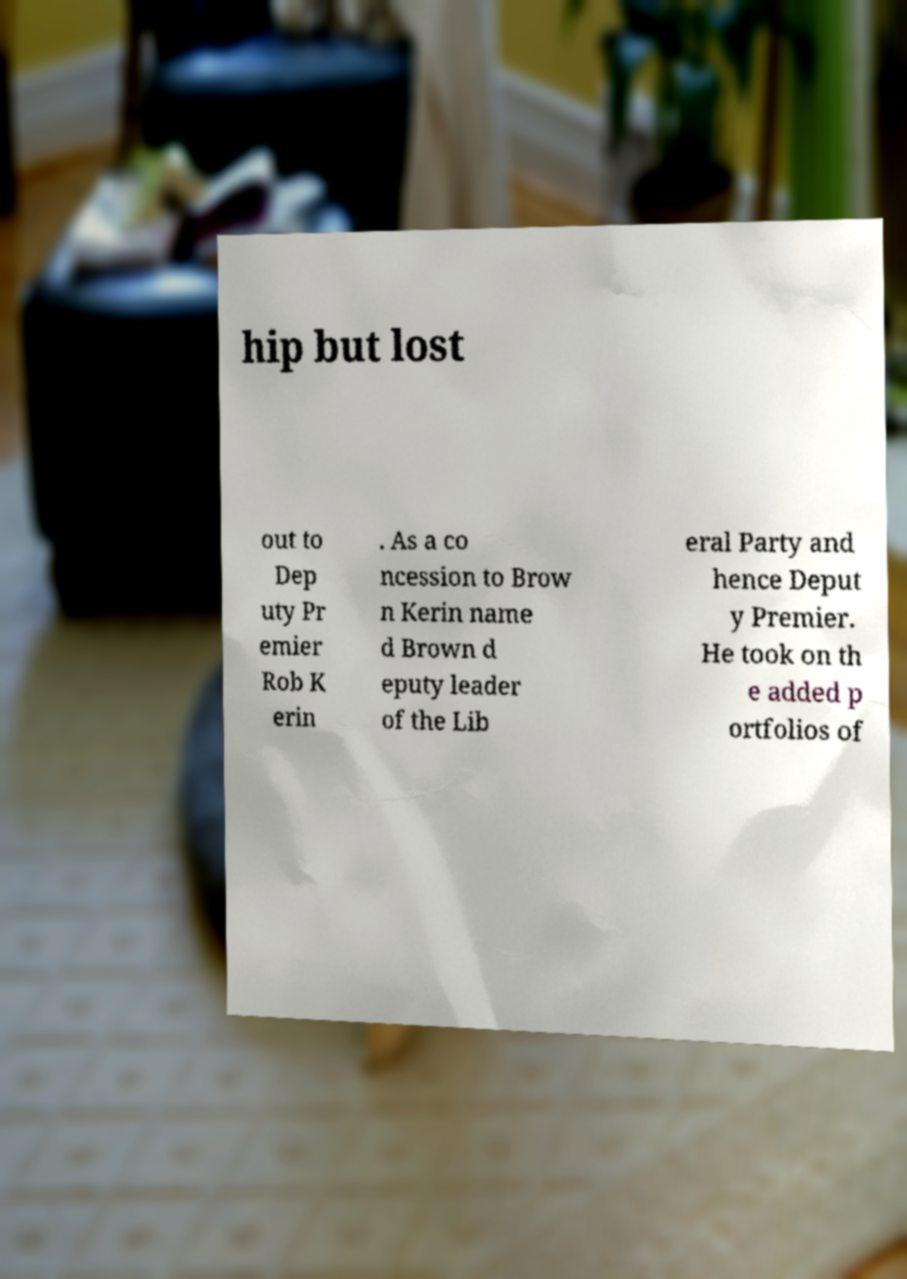Please identify and transcribe the text found in this image. hip but lost out to Dep uty Pr emier Rob K erin . As a co ncession to Brow n Kerin name d Brown d eputy leader of the Lib eral Party and hence Deput y Premier. He took on th e added p ortfolios of 